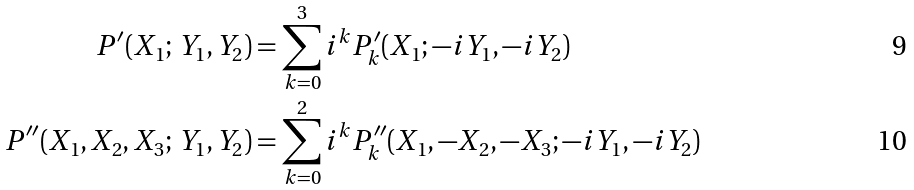<formula> <loc_0><loc_0><loc_500><loc_500>P ^ { \prime } ( X _ { 1 } ; \, Y _ { 1 } , Y _ { 2 } ) & = \sum _ { k = 0 } ^ { 3 } i ^ { k } P _ { k } ^ { \prime } ( X _ { 1 } ; - i Y _ { 1 } , - i Y _ { 2 } ) \\ P ^ { \prime \prime } ( X _ { 1 } , X _ { 2 } , X _ { 3 } ; \, Y _ { 1 } , Y _ { 2 } ) & = \sum _ { k = 0 } ^ { 2 } i ^ { k } P _ { k } ^ { \prime \prime } ( X _ { 1 } , - X _ { 2 } , - X _ { 3 } ; - i Y _ { 1 } , - i Y _ { 2 } )</formula> 